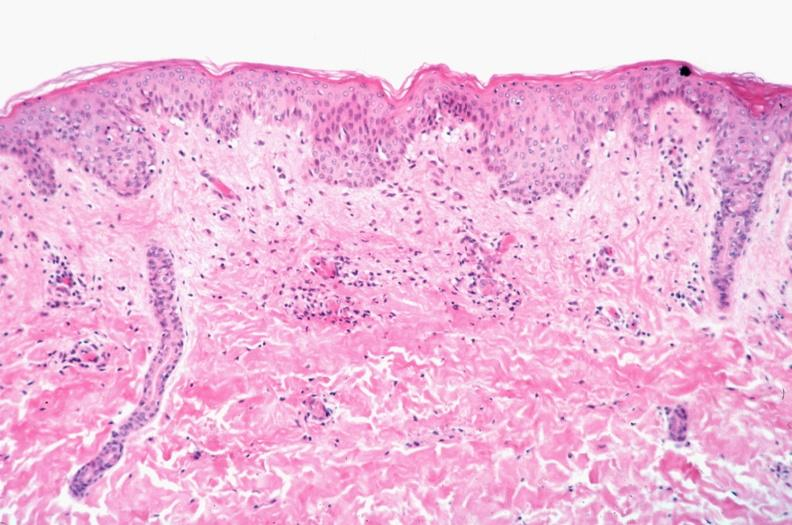s rocky mountain spotted fever, vasculitis?
Answer the question using a single word or phrase. Yes 